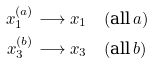Convert formula to latex. <formula><loc_0><loc_0><loc_500><loc_500>x _ { 1 } ^ { ( a ) } & \longrightarrow x _ { 1 } \quad ( \text {all} \, a ) \\ x _ { 3 } ^ { ( b ) } & \longrightarrow x _ { 3 } \quad ( \text {all} \, b )</formula> 